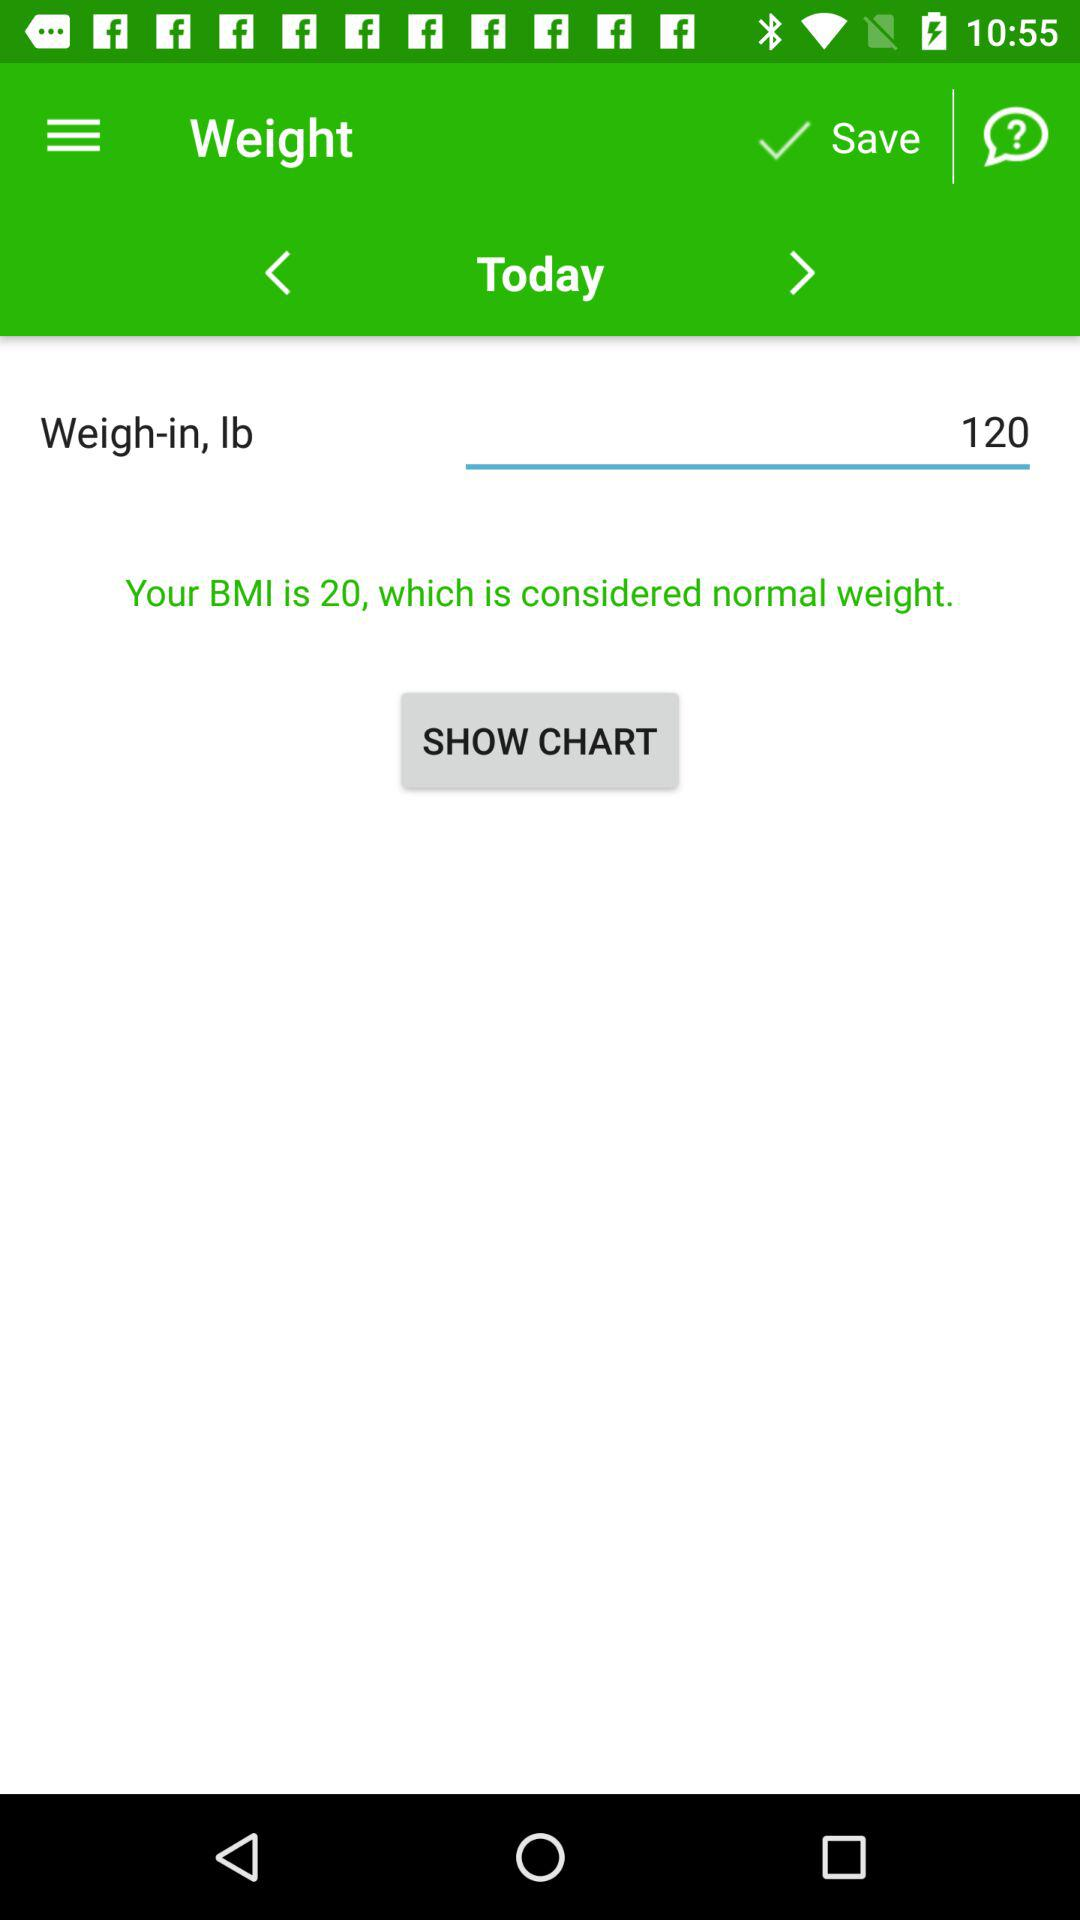What is the given weight? The given weight is 120 lbs. 